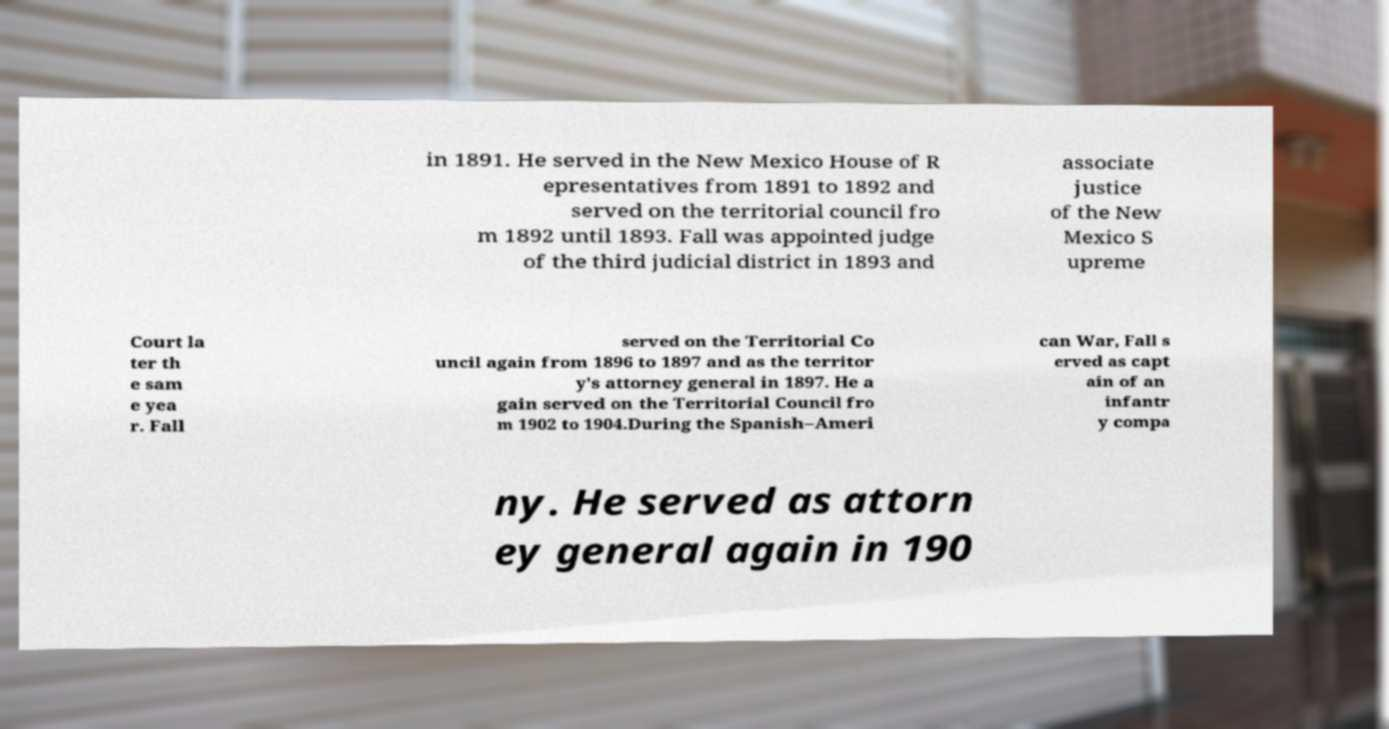Please identify and transcribe the text found in this image. in 1891. He served in the New Mexico House of R epresentatives from 1891 to 1892 and served on the territorial council fro m 1892 until 1893. Fall was appointed judge of the third judicial district in 1893 and associate justice of the New Mexico S upreme Court la ter th e sam e yea r. Fall served on the Territorial Co uncil again from 1896 to 1897 and as the territor y's attorney general in 1897. He a gain served on the Territorial Council fro m 1902 to 1904.During the Spanish–Ameri can War, Fall s erved as capt ain of an infantr y compa ny. He served as attorn ey general again in 190 